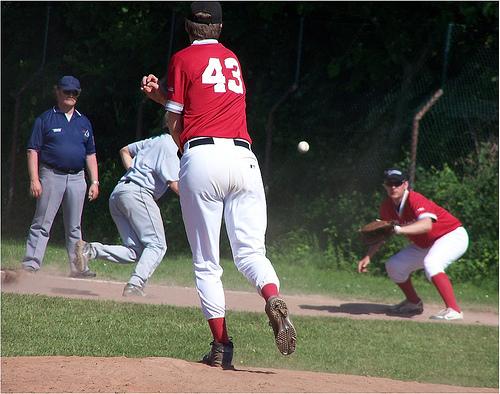Are these people professional athletes?
Quick response, please. No. What number is on the pitcher's shirt?
Give a very brief answer. 43. What team are the players from?
Write a very short answer. Baseball. What kind of game are they playing?
Concise answer only. Baseball. What number is on the players jersey?
Answer briefly. 43. What brand shoes is the pitcher wearing?
Keep it brief. Nike. Does the first base coach need the next size up in shirts?
Answer briefly. Yes. 